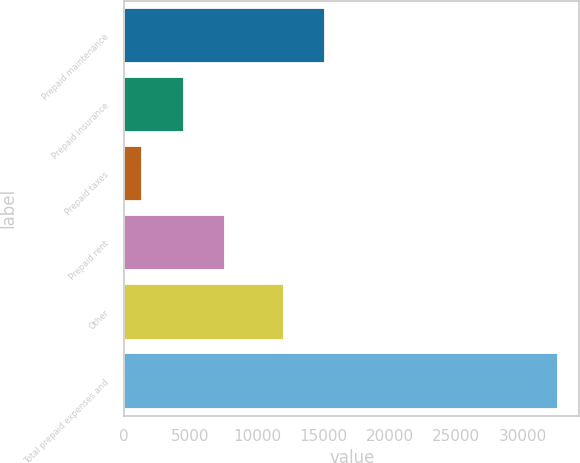Convert chart to OTSL. <chart><loc_0><loc_0><loc_500><loc_500><bar_chart><fcel>Prepaid maintenance<fcel>Prepaid insurance<fcel>Prepaid taxes<fcel>Prepaid rent<fcel>Other<fcel>Total prepaid expenses and<nl><fcel>15123.2<fcel>4491.2<fcel>1364<fcel>7618.4<fcel>11996<fcel>32636<nl></chart> 